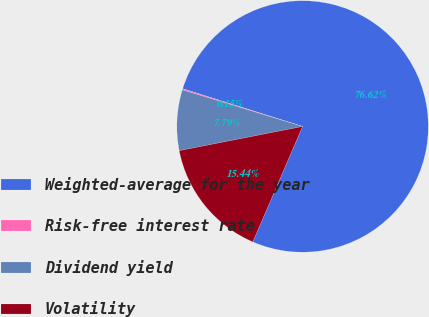Convert chart. <chart><loc_0><loc_0><loc_500><loc_500><pie_chart><fcel>Weighted-average for the year<fcel>Risk-free interest rate<fcel>Dividend yield<fcel>Volatility<nl><fcel>76.62%<fcel>0.15%<fcel>7.79%<fcel>15.44%<nl></chart> 